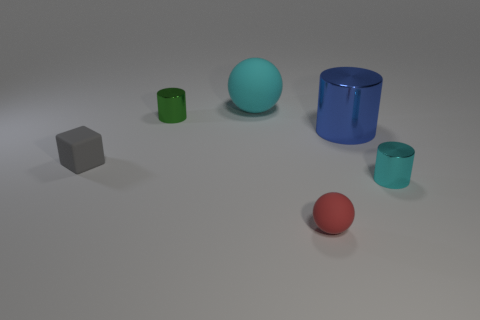What color is the thing that is behind the tiny thing behind the thing that is left of the green metallic cylinder?
Provide a succinct answer. Cyan. What number of things are either big cylinders right of the tiny red object or small things that are on the left side of the blue cylinder?
Your answer should be compact. 4. How many other objects are the same color as the tiny cube?
Your response must be concise. 0. There is a small metallic object that is behind the cyan metallic thing; is it the same shape as the blue object?
Your response must be concise. Yes. Is the number of small cubes behind the tiny matte sphere less than the number of big spheres?
Offer a very short reply. No. Are there any cyan spheres that have the same material as the red sphere?
Your answer should be compact. Yes. There is another object that is the same size as the cyan matte thing; what material is it?
Provide a succinct answer. Metal. Are there fewer gray things that are in front of the small red object than cylinders that are right of the tiny green metal object?
Your answer should be very brief. Yes. What is the shape of the object that is both in front of the blue metallic object and to the right of the small red sphere?
Make the answer very short. Cylinder. What number of green metal things have the same shape as the gray object?
Ensure brevity in your answer.  0. 